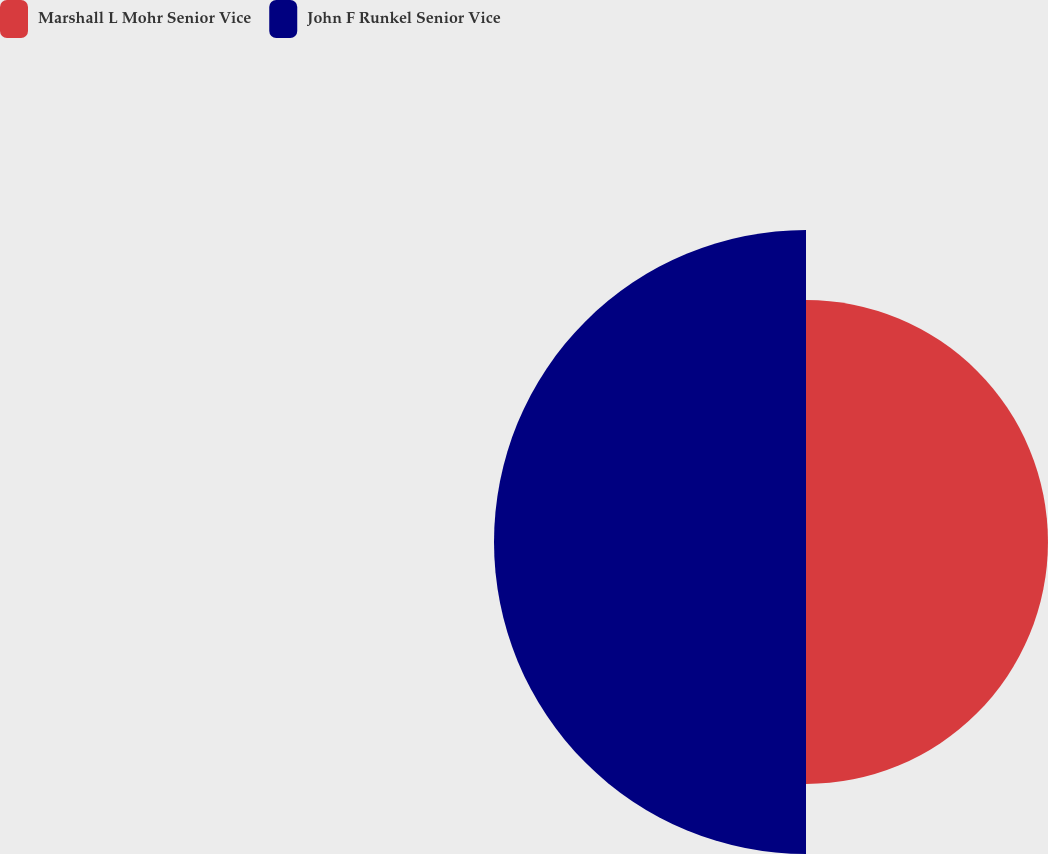Convert chart. <chart><loc_0><loc_0><loc_500><loc_500><pie_chart><fcel>Marshall L Mohr Senior Vice<fcel>John F Runkel Senior Vice<nl><fcel>43.68%<fcel>56.32%<nl></chart> 